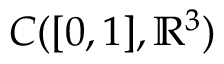<formula> <loc_0><loc_0><loc_500><loc_500>C ( [ 0 , 1 ] , \mathbb { R } ^ { 3 } )</formula> 